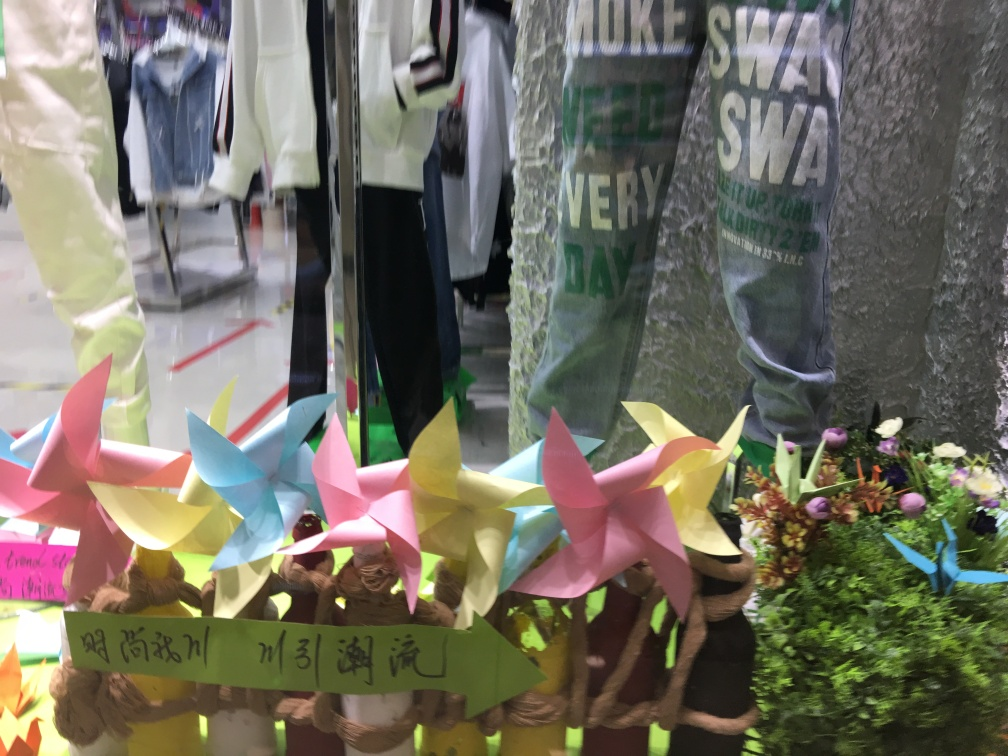What is the possible context or setting of this image? The context seems to be a retail setting, perhaps a store or a boutique with a display window. The presence of the pinwheels and flowers suggests a special sale, event, or a thematic decorative setup to attract customers. The writing on the green band might contain information about the event but is partially obscured, making it difficult to derive the exact context. 